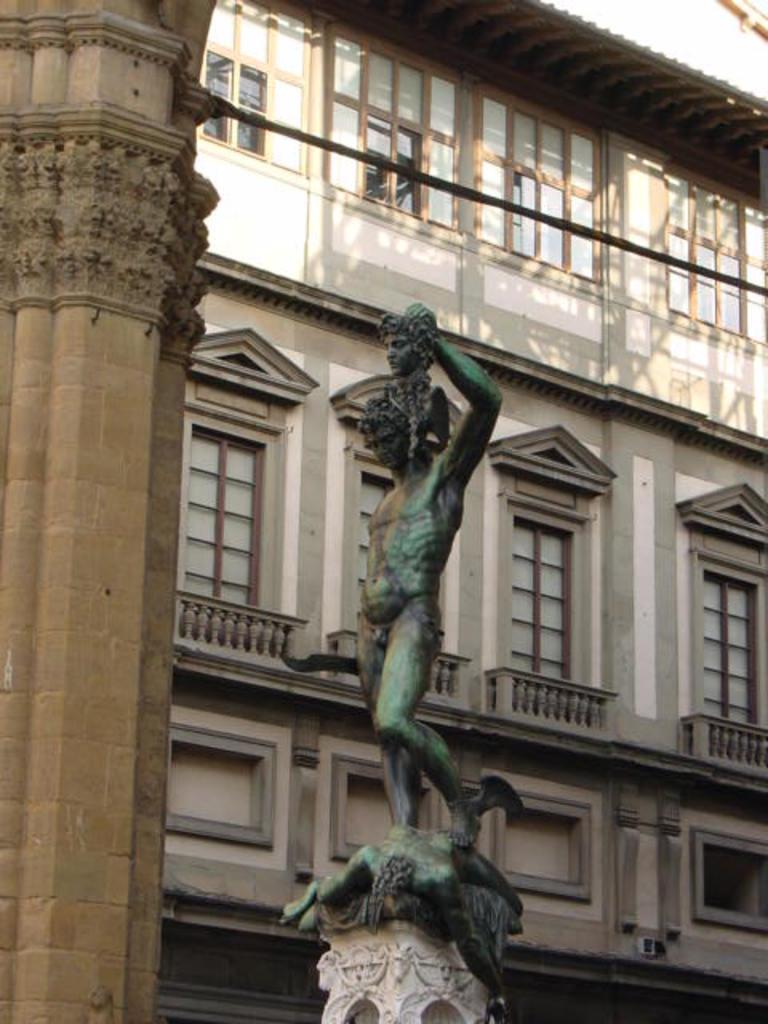What is the main subject in the center of the image? There is a sculpture in the center of the image. What supports the sculpture? There is a pedestal at the bottom of the sculpture. What can be seen in the background of the image? There is a building in the background of the image. What other architectural feature is visible in the image? There is a pillar on the left side of the image. What level of experience does the beginner sculptor have in the image? There is no indication of a sculptor or their experience level in the image; it only shows a sculpture and its surroundings. What type of ring can be seen on the sculpture's finger in the image? There is no ring visible on any part of the sculpture in the image. 